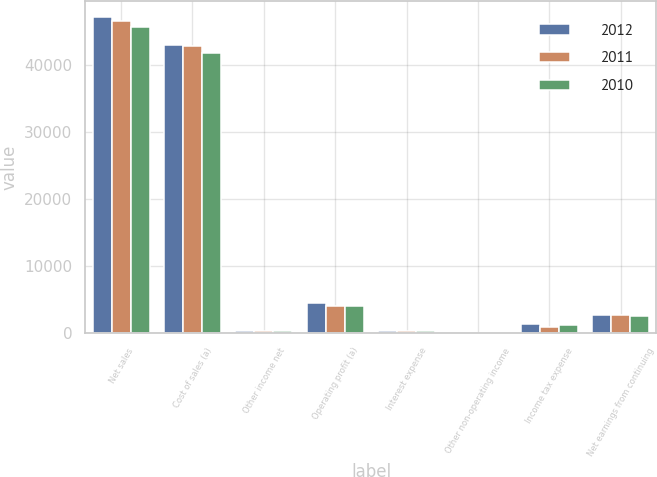<chart> <loc_0><loc_0><loc_500><loc_500><stacked_bar_chart><ecel><fcel>Net sales<fcel>Cost of sales (a)<fcel>Other income net<fcel>Operating profit (a)<fcel>Interest expense<fcel>Other non-operating income<fcel>Income tax expense<fcel>Net earnings from continuing<nl><fcel>2012<fcel>47182<fcel>42986<fcel>238<fcel>4434<fcel>383<fcel>21<fcel>1327<fcel>2745<nl><fcel>2011<fcel>46499<fcel>42755<fcel>276<fcel>4020<fcel>354<fcel>35<fcel>964<fcel>2667<nl><fcel>2010<fcel>45671<fcel>41827<fcel>261<fcel>4105<fcel>345<fcel>18<fcel>1164<fcel>2614<nl></chart> 